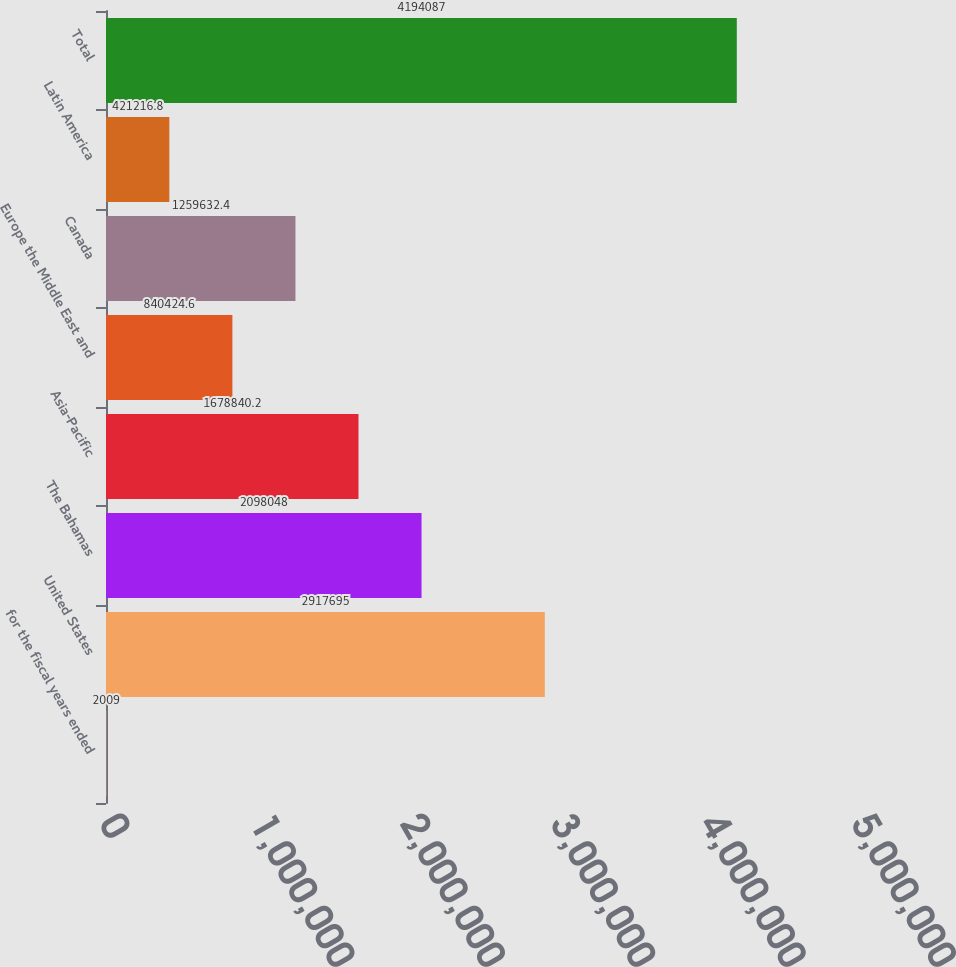Convert chart to OTSL. <chart><loc_0><loc_0><loc_500><loc_500><bar_chart><fcel>for the fiscal years ended<fcel>United States<fcel>The Bahamas<fcel>Asia-Pacific<fcel>Europe the Middle East and<fcel>Canada<fcel>Latin America<fcel>Total<nl><fcel>2009<fcel>2.9177e+06<fcel>2.09805e+06<fcel>1.67884e+06<fcel>840425<fcel>1.25963e+06<fcel>421217<fcel>4.19409e+06<nl></chart> 